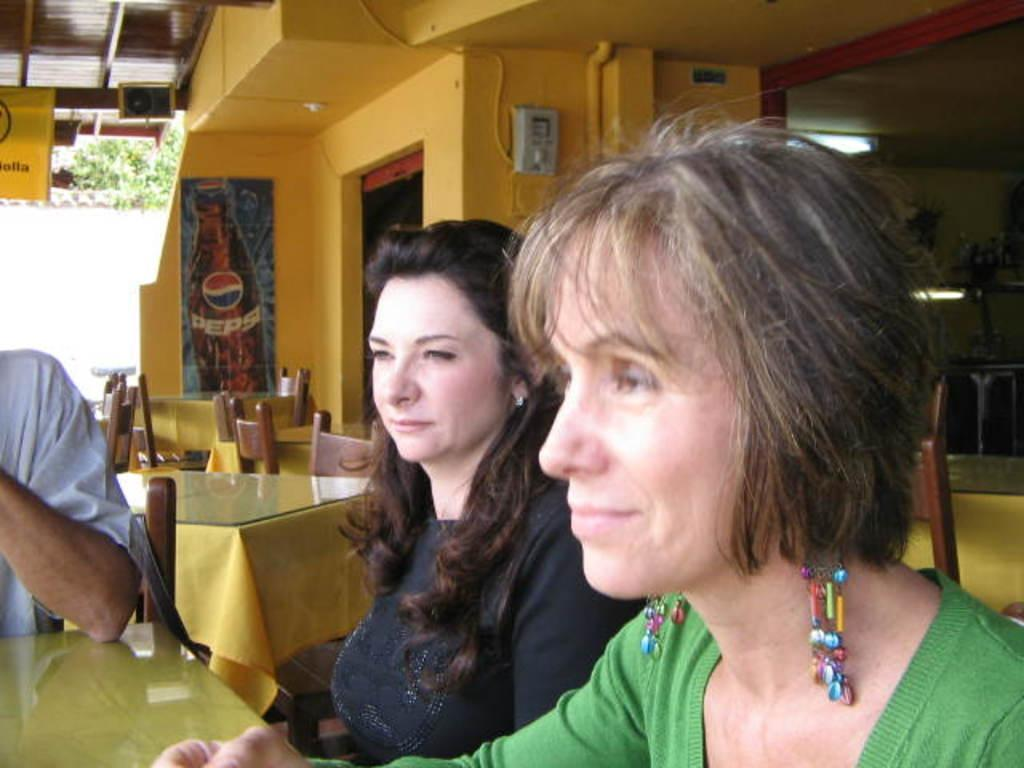How many people are present in the image? There are three people in the image. What type of furniture is in the image? There is a table and four chairs in the image. What is on the wall in the image? There is a poster on the wall in the image. What architectural feature is present in the image? There is a door in the image. What part of the building is visible in the image? The roof is visible at the top of the image. What type of spot does the grandmother have on her forehead in the image? There is no grandmother or spot on anyone's forehead present in the image. 